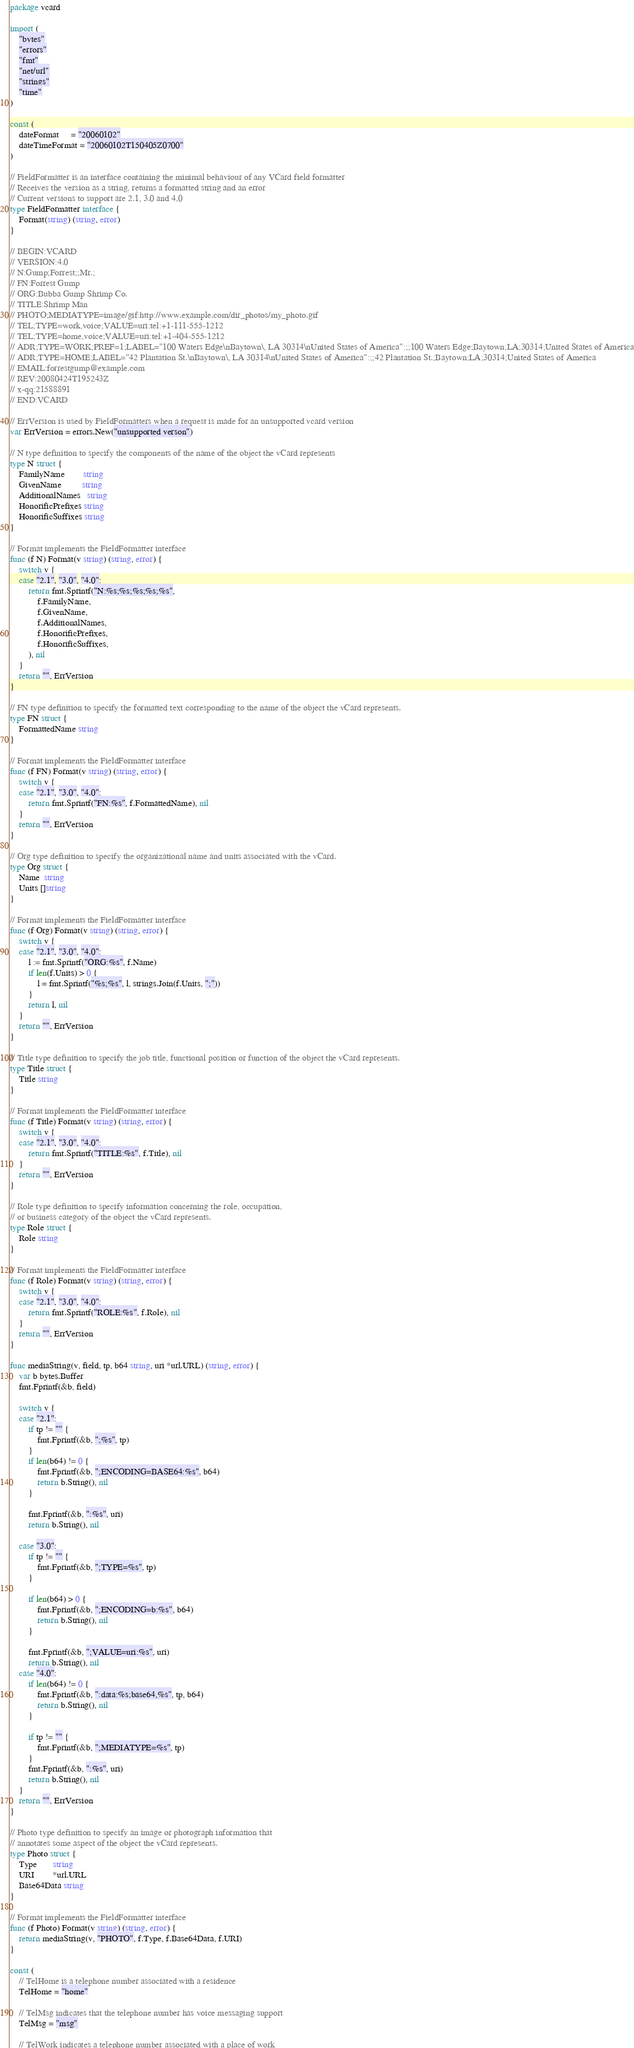Convert code to text. <code><loc_0><loc_0><loc_500><loc_500><_Go_>package vcard

import (
	"bytes"
	"errors"
	"fmt"
	"net/url"
	"strings"
	"time"
)

const (
	dateFormat     = "20060102"
	dateTimeFormat = "20060102T150405Z0700"
)

// FieldFormatter is an interface containing the minimal behaviour of any VCard field formatter
// Receives the version as a string, returns a formatted string and an error
// Current versions to support are 2.1, 3.0 and 4,0
type FieldFormatter interface {
	Format(string) (string, error)
}

// BEGIN:VCARD
// VERSION:4.0
// N:Gump;Forrest;;Mr.;
// FN:Forrest Gump
// ORG:Bubba Gump Shrimp Co.
// TITLE:Shrimp Man
// PHOTO;MEDIATYPE=image/gif:http://www.example.com/dir_photos/my_photo.gif
// TEL;TYPE=work,voice;VALUE=uri:tel:+1-111-555-1212
// TEL;TYPE=home,voice;VALUE=uri:tel:+1-404-555-1212
// ADR;TYPE=WORK;PREF=1;LABEL="100 Waters Edge\nBaytown\, LA 30314\nUnited States of America":;;100 Waters Edge;Baytown;LA;30314;United States of America
// ADR;TYPE=HOME;LABEL="42 Plantation St.\nBaytown\, LA 30314\nUnited States of America":;;42 Plantation St.;Baytown;LA;30314;United States of America
// EMAIL:forrestgump@example.com
// REV:20080424T195243Z
// x-qq:21588891
// END:VCARD

// ErrVersion is used by FieldFormatters when a request is made for an unsupported vcard version
var ErrVersion = errors.New("unsupported verson")

// N type definition to specify the components of the name of the object the vCard represents
type N struct {
	FamilyName        string
	GivenName         string
	AdditionalNames   string
	HonorificPrefixes string
	HonorificSuffixes string
}

// Format implements the FieldFormatter interface
func (f N) Format(v string) (string, error) {
	switch v {
	case "2.1", "3.0", "4.0":
		return fmt.Sprintf("N:%s;%s;%s;%s;%s",
			f.FamilyName,
			f.GivenName,
			f.AdditionalNames,
			f.HonorificPrefixes,
			f.HonorificSuffixes,
		), nil
	}
	return "", ErrVersion
}

// FN type definition to specify the formatted text corresponding to the name of the object the vCard represents.
type FN struct {
	FormattedName string
}

// Format implements the FieldFormatter interface
func (f FN) Format(v string) (string, error) {
	switch v {
	case "2.1", "3.0", "4.0":
		return fmt.Sprintf("FN:%s", f.FormattedName), nil
	}
	return "", ErrVersion
}

// Org type definition to specify the organizational name and units associated with the vCard.
type Org struct {
	Name  string
	Units []string
}

// Format implements the FieldFormatter interface
func (f Org) Format(v string) (string, error) {
	switch v {
	case "2.1", "3.0", "4.0":
		l := fmt.Sprintf("ORG:%s", f.Name)
		if len(f.Units) > 0 {
			l = fmt.Sprintf("%s;%s", l, strings.Join(f.Units, ";"))
		}
		return l, nil
	}
	return "", ErrVersion
}

// Title type definition to specify the job title, functional position or function of the object the vCard represents.
type Title struct {
	Title string
}

// Format implements the FieldFormatter interface
func (f Title) Format(v string) (string, error) {
	switch v {
	case "2.1", "3.0", "4.0":
		return fmt.Sprintf("TITLE:%s", f.Title), nil
	}
	return "", ErrVersion
}

// Role type definition to specify information concerning the role, occupation,
// or business category of the object the vCard represents.
type Role struct {
	Role string
}

// Format implements the FieldFormatter interface
func (f Role) Format(v string) (string, error) {
	switch v {
	case "2.1", "3.0", "4.0":
		return fmt.Sprintf("ROLE:%s", f.Role), nil
	}
	return "", ErrVersion
}

func mediaString(v, field, tp, b64 string, uri *url.URL) (string, error) {
	var b bytes.Buffer
	fmt.Fprintf(&b, field)

	switch v {
	case "2.1":
		if tp != "" {
			fmt.Fprintf(&b, ";%s", tp)
		}
		if len(b64) != 0 {
			fmt.Fprintf(&b, ";ENCODING=BASE64:%s", b64)
			return b.String(), nil
		}

		fmt.Fprintf(&b, ":%s", uri)
		return b.String(), nil

	case "3.0":
		if tp != "" {
			fmt.Fprintf(&b, ";TYPE=%s", tp)
		}

		if len(b64) > 0 {
			fmt.Fprintf(&b, ";ENCODING=b:%s", b64)
			return b.String(), nil
		}

		fmt.Fprintf(&b, ";VALUE=uri:%s", uri)
		return b.String(), nil
	case "4.0":
		if len(b64) != 0 {
			fmt.Fprintf(&b, ":data:%s;base64,%s", tp, b64)
			return b.String(), nil
		}

		if tp != "" {
			fmt.Fprintf(&b, ";MEDIATYPE=%s", tp)
		}
		fmt.Fprintf(&b, ":%s", uri)
		return b.String(), nil
	}
	return "", ErrVersion
}

// Photo type definition to specify an image or photograph information that
// annotates some aspect of the object the vCard represents.
type Photo struct {
	Type       string
	URI        *url.URL
	Base64Data string
}

// Format implements the FieldFormatter interface
func (f Photo) Format(v string) (string, error) {
	return mediaString(v, "PHOTO", f.Type, f.Base64Data, f.URI)
}

const (
	// TelHome is a telephone number associated with a residence
	TelHome = "home"

	// TelMsg indicates that the telephone number has voice messaging support
	TelMsg = "msg"

	// TelWork indicates a telephone number associated with a place of work</code> 